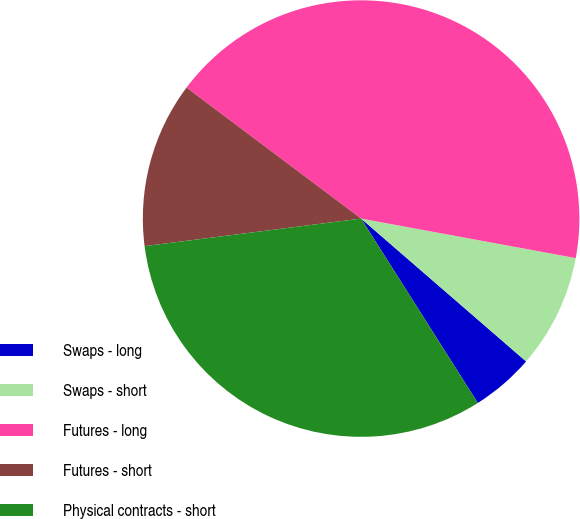Convert chart to OTSL. <chart><loc_0><loc_0><loc_500><loc_500><pie_chart><fcel>Swaps - long<fcel>Swaps - short<fcel>Futures - long<fcel>Futures - short<fcel>Physical contracts - short<nl><fcel>4.66%<fcel>8.46%<fcel>42.65%<fcel>12.26%<fcel>31.96%<nl></chart> 